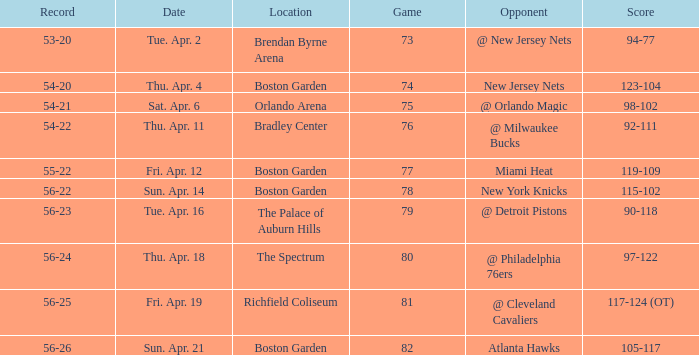Which Opponent has a Score of 92-111? @ Milwaukee Bucks. 